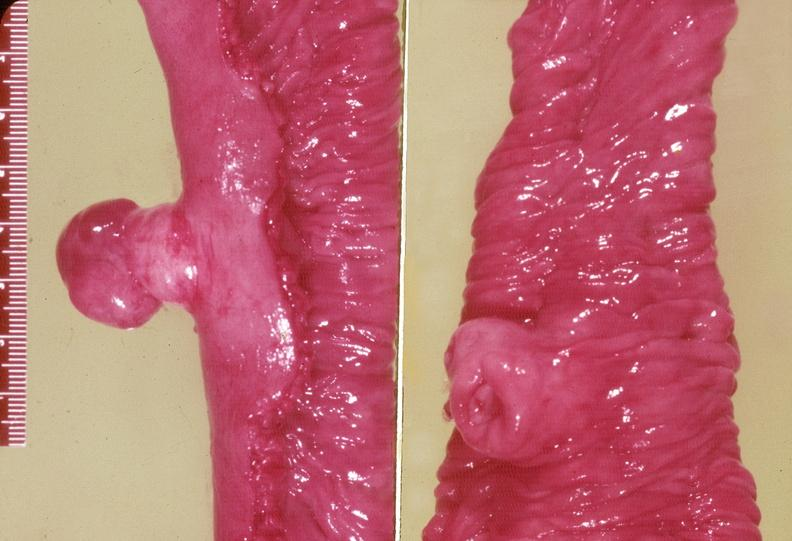does this image show gejunum, leiomyoma?
Answer the question using a single word or phrase. Yes 